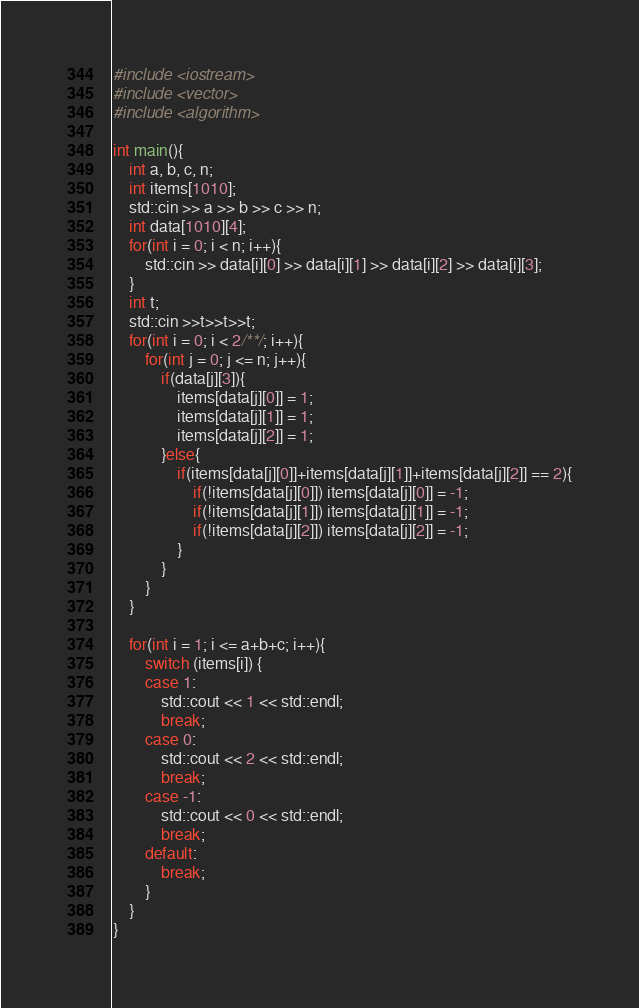<code> <loc_0><loc_0><loc_500><loc_500><_C++_>#include <iostream>
#include <vector>
#include <algorithm>

int main(){
    int a, b, c, n;
    int items[1010];
    std::cin >> a >> b >> c >> n;
    int data[1010][4];
    for(int i = 0; i < n; i++){
        std::cin >> data[i][0] >> data[i][1] >> data[i][2] >> data[i][3];
    }
    int t;
    std::cin >>t>>t>>t;
    for(int i = 0; i < 2/**/; i++){
        for(int j = 0; j <= n; j++){
            if(data[j][3]){
                items[data[j][0]] = 1;
                items[data[j][1]] = 1;
                items[data[j][2]] = 1;
            }else{
                if(items[data[j][0]]+items[data[j][1]]+items[data[j][2]] == 2){
                    if(!items[data[j][0]]) items[data[j][0]] = -1;
                    if(!items[data[j][1]]) items[data[j][1]] = -1;
                    if(!items[data[j][2]]) items[data[j][2]] = -1;
                }
            }
        }
    }

    for(int i = 1; i <= a+b+c; i++){
        switch (items[i]) {
        case 1:
            std::cout << 1 << std::endl;
            break;
        case 0:
            std::cout << 2 << std::endl;
            break;
        case -1:
            std::cout << 0 << std::endl;
            break;
        default:
            break;
        }
    }
}

</code> 